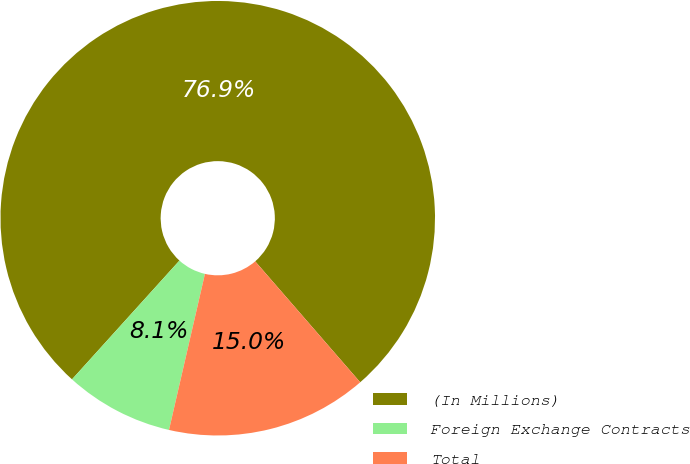Convert chart. <chart><loc_0><loc_0><loc_500><loc_500><pie_chart><fcel>(In Millions)<fcel>Foreign Exchange Contracts<fcel>Total<nl><fcel>76.91%<fcel>8.1%<fcel>14.98%<nl></chart> 